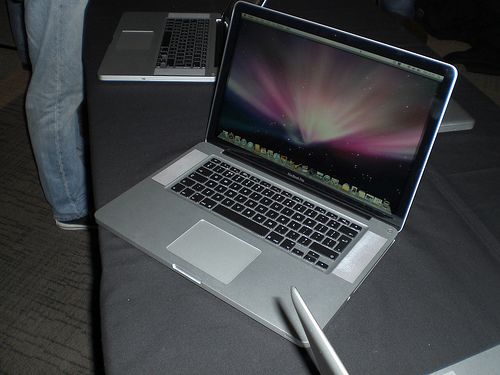<image>
Is there a pen on the laptop? Yes. Looking at the image, I can see the pen is positioned on top of the laptop, with the laptop providing support. Is the laptop on the table? Yes. Looking at the image, I can see the laptop is positioned on top of the table, with the table providing support. Is the shoe behind the screen? No. The shoe is not behind the screen. From this viewpoint, the shoe appears to be positioned elsewhere in the scene. 